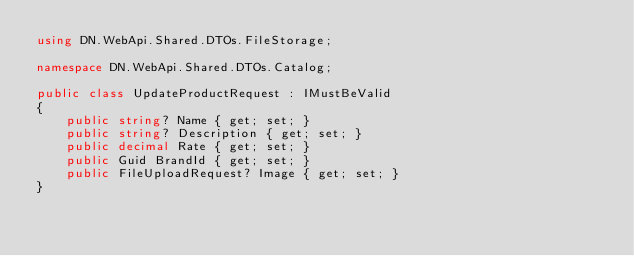Convert code to text. <code><loc_0><loc_0><loc_500><loc_500><_C#_>using DN.WebApi.Shared.DTOs.FileStorage;

namespace DN.WebApi.Shared.DTOs.Catalog;

public class UpdateProductRequest : IMustBeValid
{
    public string? Name { get; set; }
    public string? Description { get; set; }
    public decimal Rate { get; set; }
    public Guid BrandId { get; set; }
    public FileUploadRequest? Image { get; set; }
}</code> 